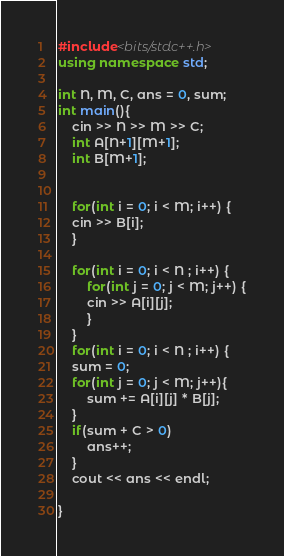<code> <loc_0><loc_0><loc_500><loc_500><_C++_>#include<bits/stdc++.h>
using namespace std;

int N, M, C, ans = 0, sum;
int main(){
    cin >> N >> M >> C;
    int A[N+1][M+1];
    int B[M+1];


    for(int i = 0; i < M; i++) {
	cin >> B[i];
    }

    for(int i = 0; i < N ; i++) {
	    for(int j = 0; j < M; j++) {
		cin >> A[i][j];
	    }
    }
    for(int i = 0; i < N ; i++) {
	sum = 0;
	for(int j = 0; j < M; j++){
	    sum += A[i][j] * B[j];
	}
	if(sum + C > 0)
	    ans++;	
    }
    cout << ans << endl; 
	      
}
</code> 